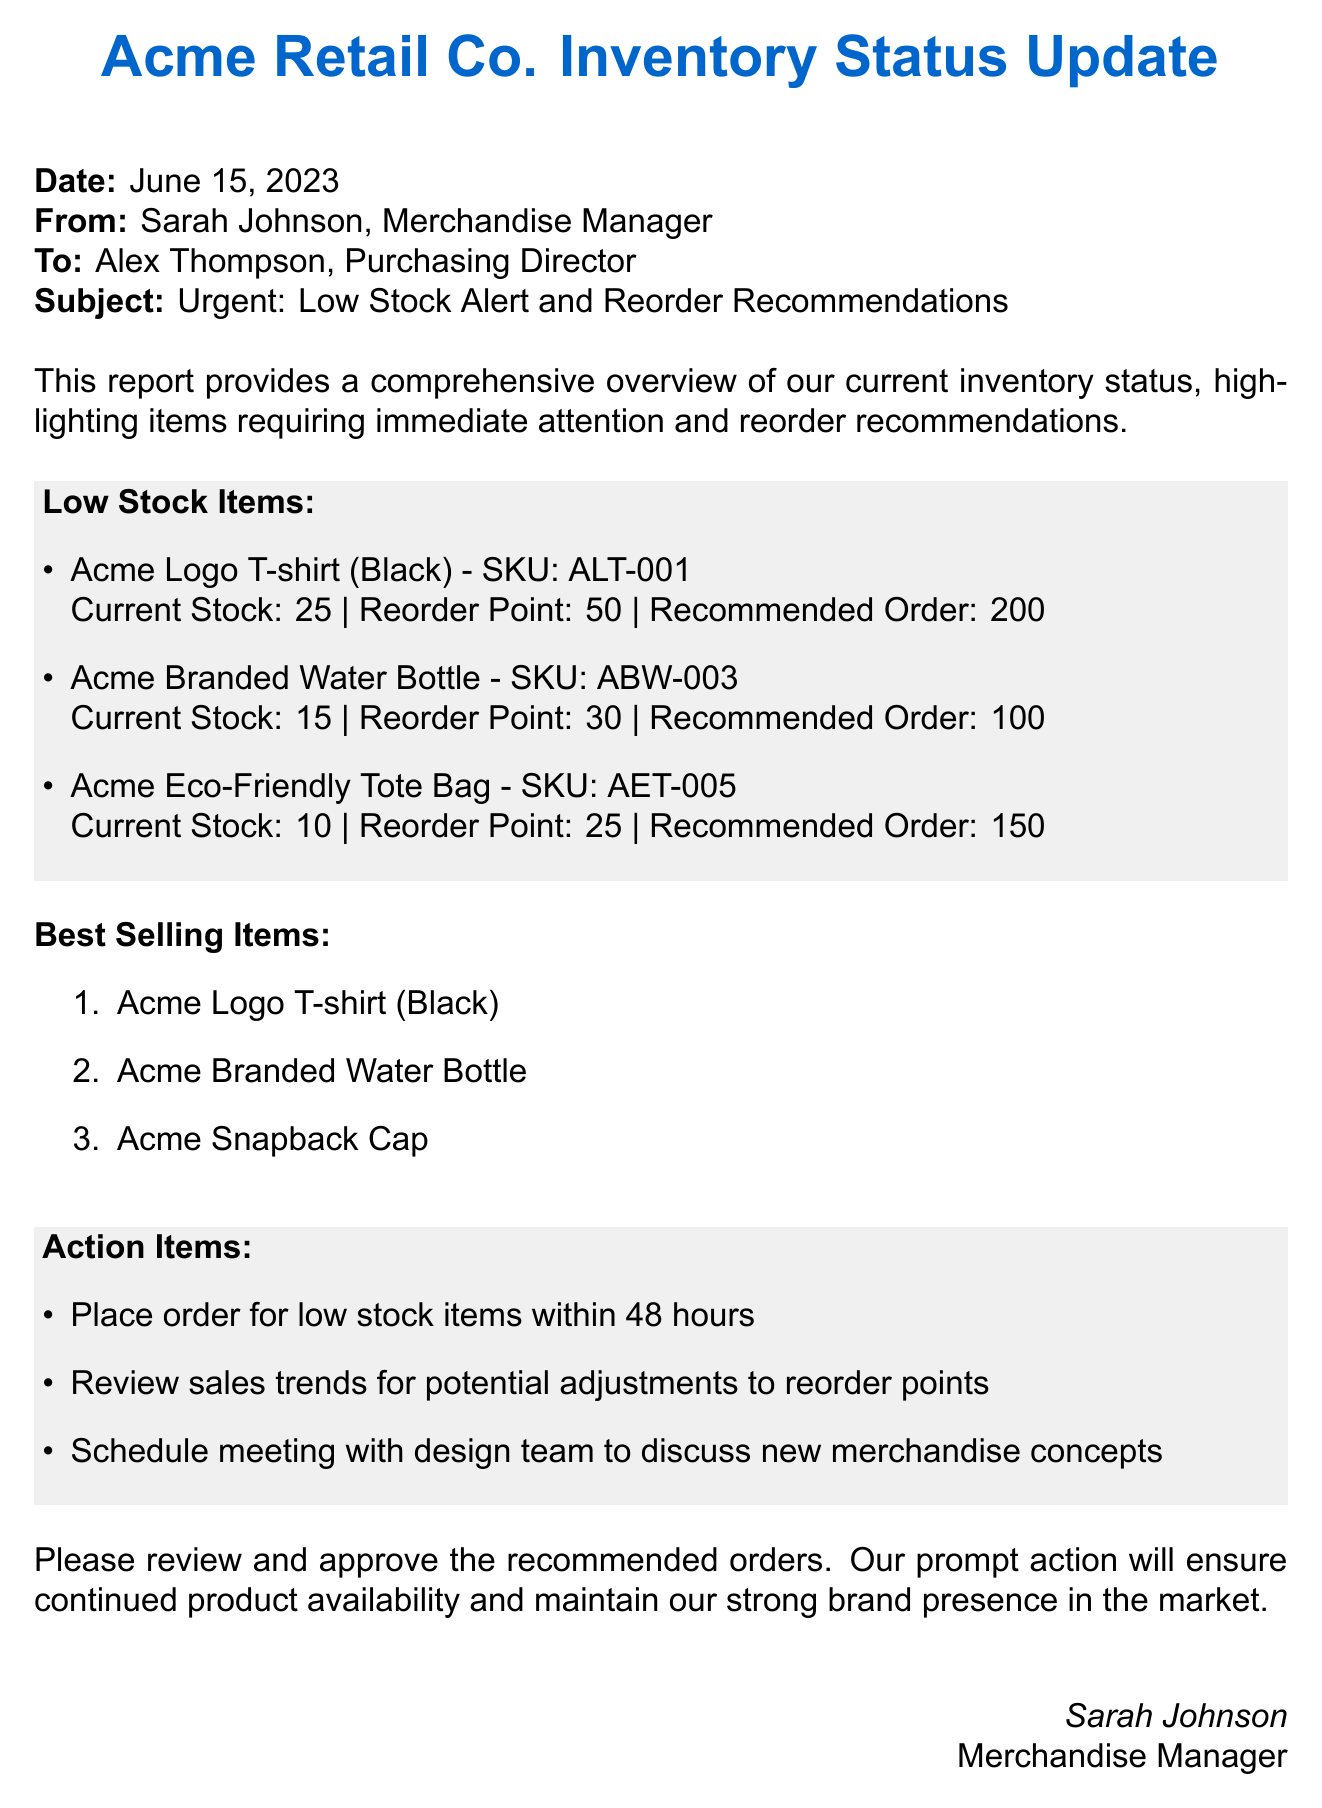What is the date of the inventory report? The date is specified at the beginning of the report.
Answer: June 15, 2023 Who is the merchandise manager? The sender of the document is indicated in the communication header.
Answer: Sarah Johnson How many Acme Logo T-shirts are currently in stock? The current stock quantity for the Acme Logo T-shirt is listed under low stock items.
Answer: 25 What is the reorder point for the Acme Branded Water Bottle? The reorder point is mentioned with each low stock item.
Answer: 30 What is the recommended order quantity for the Acme Eco-Friendly Tote Bag? The recommended order is indicated under low stock items for the tote bag.
Answer: 150 Which item is listed as the best selling item first? The list of best-selling items starts with the top-selling product.
Answer: Acme Logo T-shirt (Black) What action is recommended to be completed within 48 hours? Action items listed include specific tasks with timeframes for completion.
Answer: Place order for low stock items How many low stock items are listed in the document? The low stock items are numbered under one of the highlighted sections.
Answer: 3 What position does Alex Thompson hold? The recipient's title is indicated in the communication header of the document.
Answer: Purchasing Director 